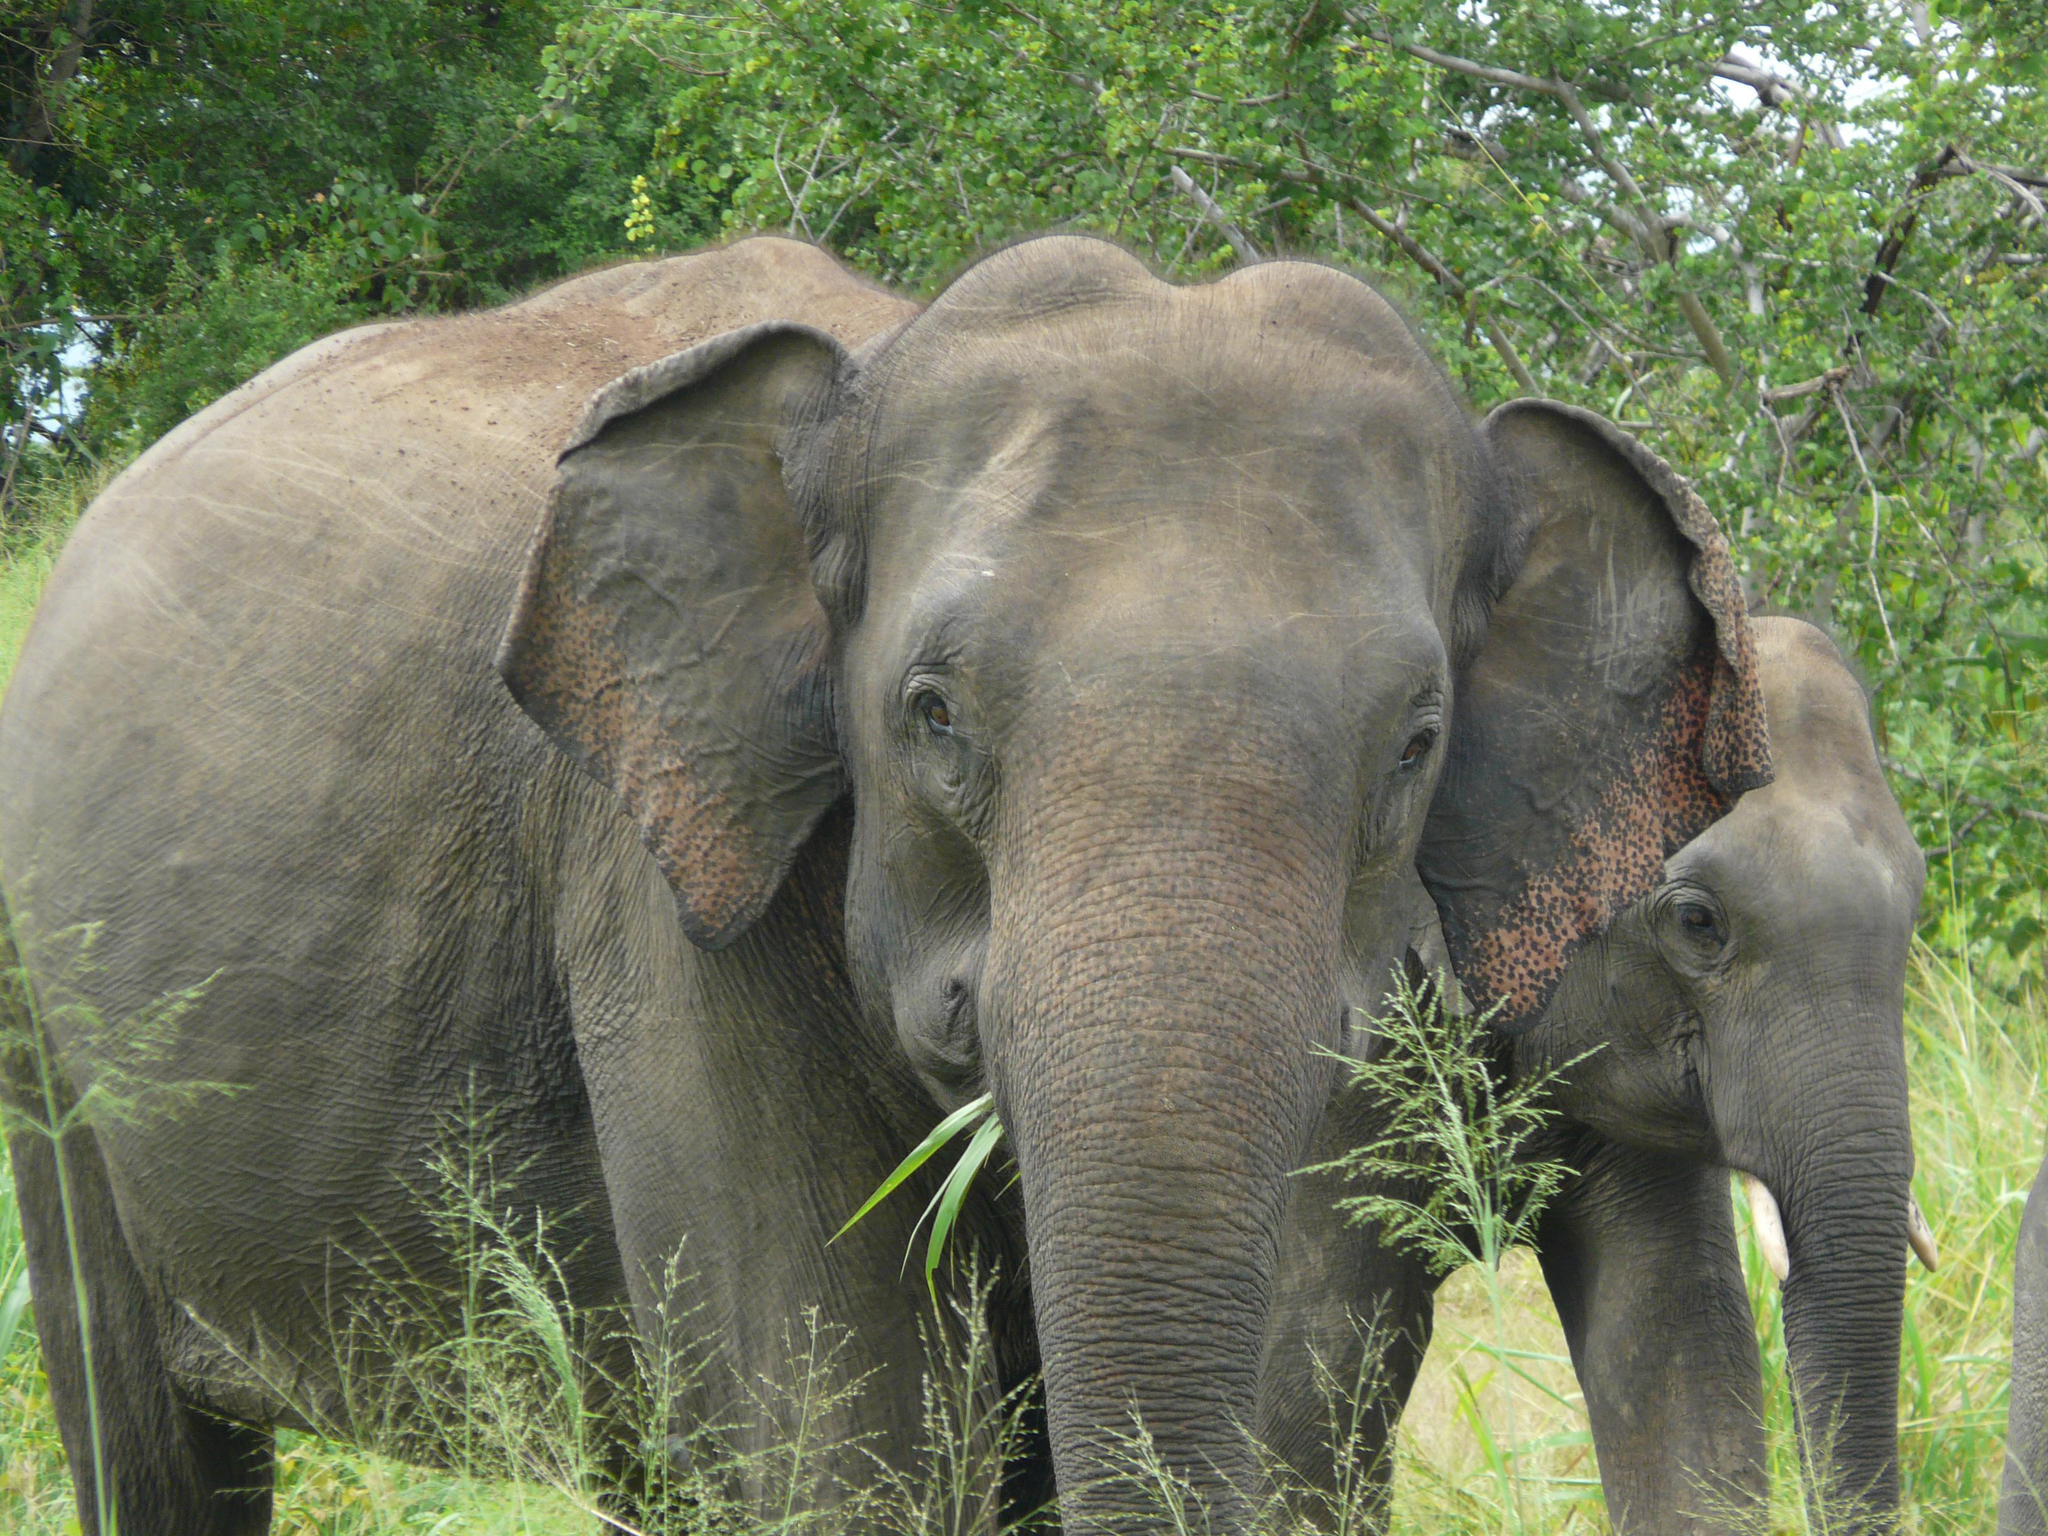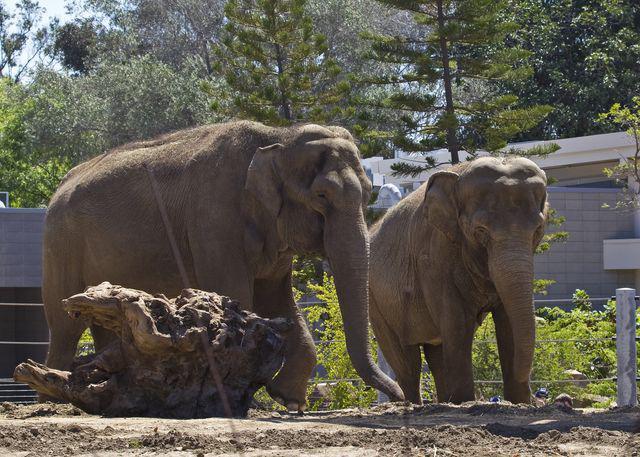The first image is the image on the left, the second image is the image on the right. Considering the images on both sides, is "An image shows two adult elephants next to a baby elephant." valid? Answer yes or no. No. The first image is the image on the left, the second image is the image on the right. Assess this claim about the two images: "The elephants in the image on the right are butting heads.". Correct or not? Answer yes or no. No. 